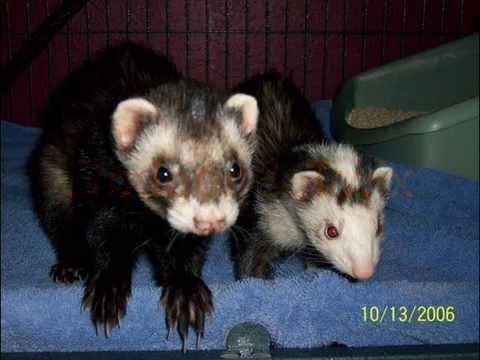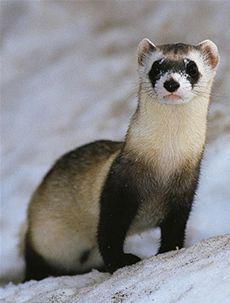The first image is the image on the left, the second image is the image on the right. Evaluate the accuracy of this statement regarding the images: "At least one ferret has its front paws draped over an edge, and multiple ferrets are peering forward.". Is it true? Answer yes or no. Yes. 